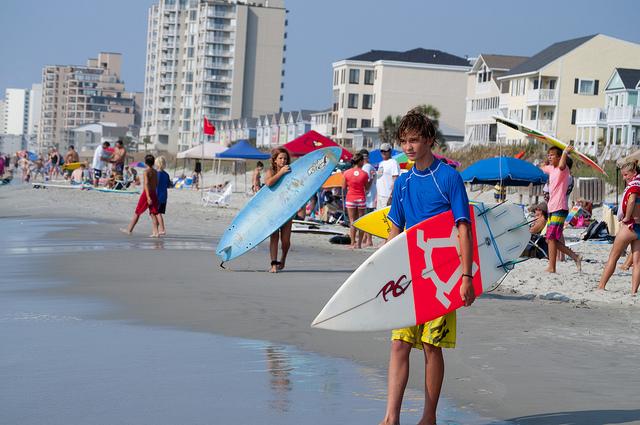Are there anyone wearing shoes?
Concise answer only. No. Is the man's surfboard name brand?
Answer briefly. Yes. What are the buildings?
Keep it brief. Hotels. 